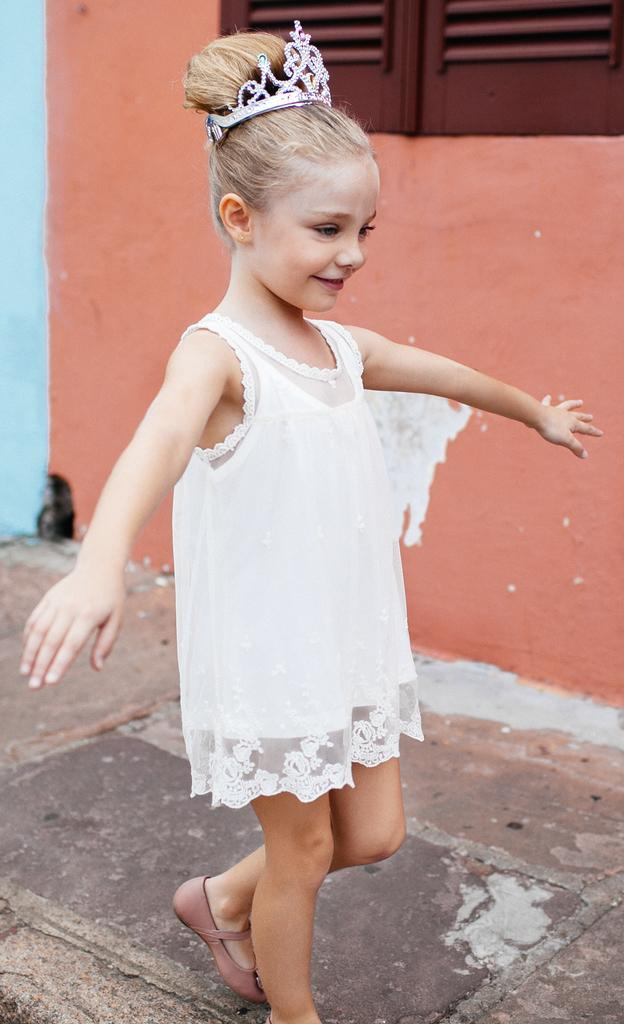Who is the main subject in the image? There is a girl in the image. What is the girl doing in the image? The girl is standing. What is the girl wearing in the image? The girl is wearing a white dress. What accessory is the girl wearing on her head? The girl has a crown on her head. What can be seen in the background of the image? There is an orange color wall and a wooden window in the background. What type of plot is the girl standing on in the image? There is no plot visible in the image; the girl is standing on a surface that is not discernible from the provided facts. 